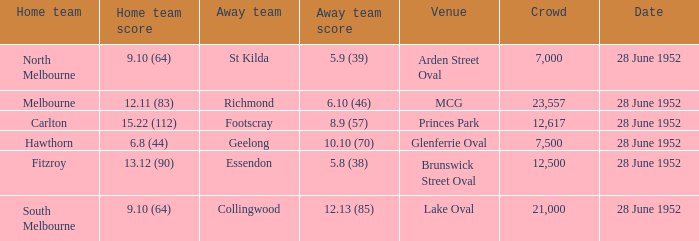What is the host team's score when the location is princes park? 15.22 (112). 